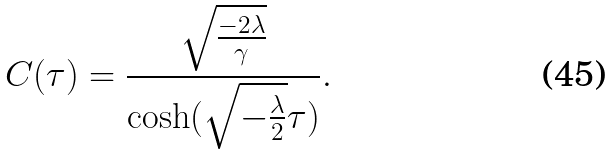<formula> <loc_0><loc_0><loc_500><loc_500>C ( \tau ) = \frac { \sqrt { \frac { - 2 \lambda } { \gamma } } } { \cosh ( \sqrt { - \frac { \lambda } { 2 } } \tau ) } .</formula> 